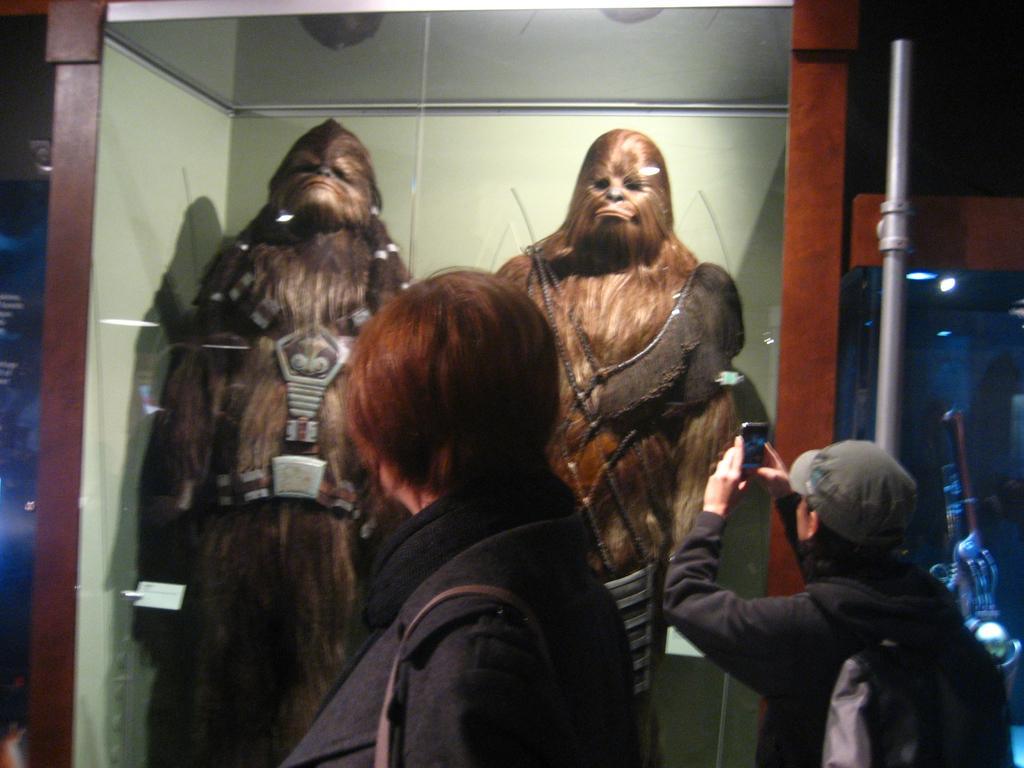Could you give a brief overview of what you see in this image? In this image there are people, animals, glass box, pipe, light and objects. Inside the glass box there are animals. Among the two people one person wore a bag and holding a mobile. 